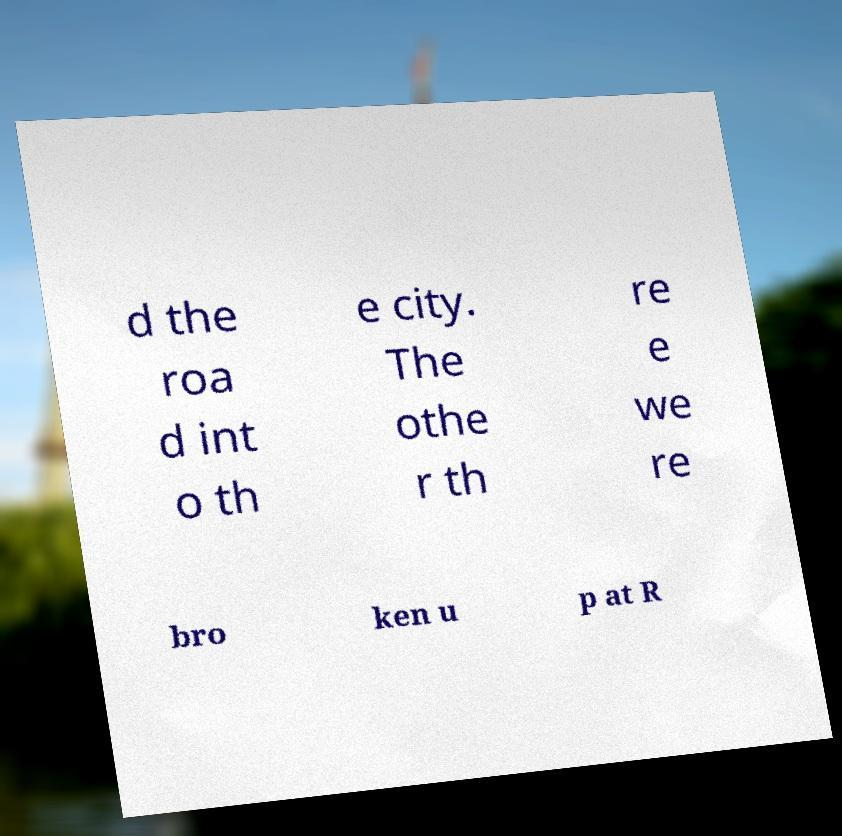For documentation purposes, I need the text within this image transcribed. Could you provide that? d the roa d int o th e city. The othe r th re e we re bro ken u p at R 